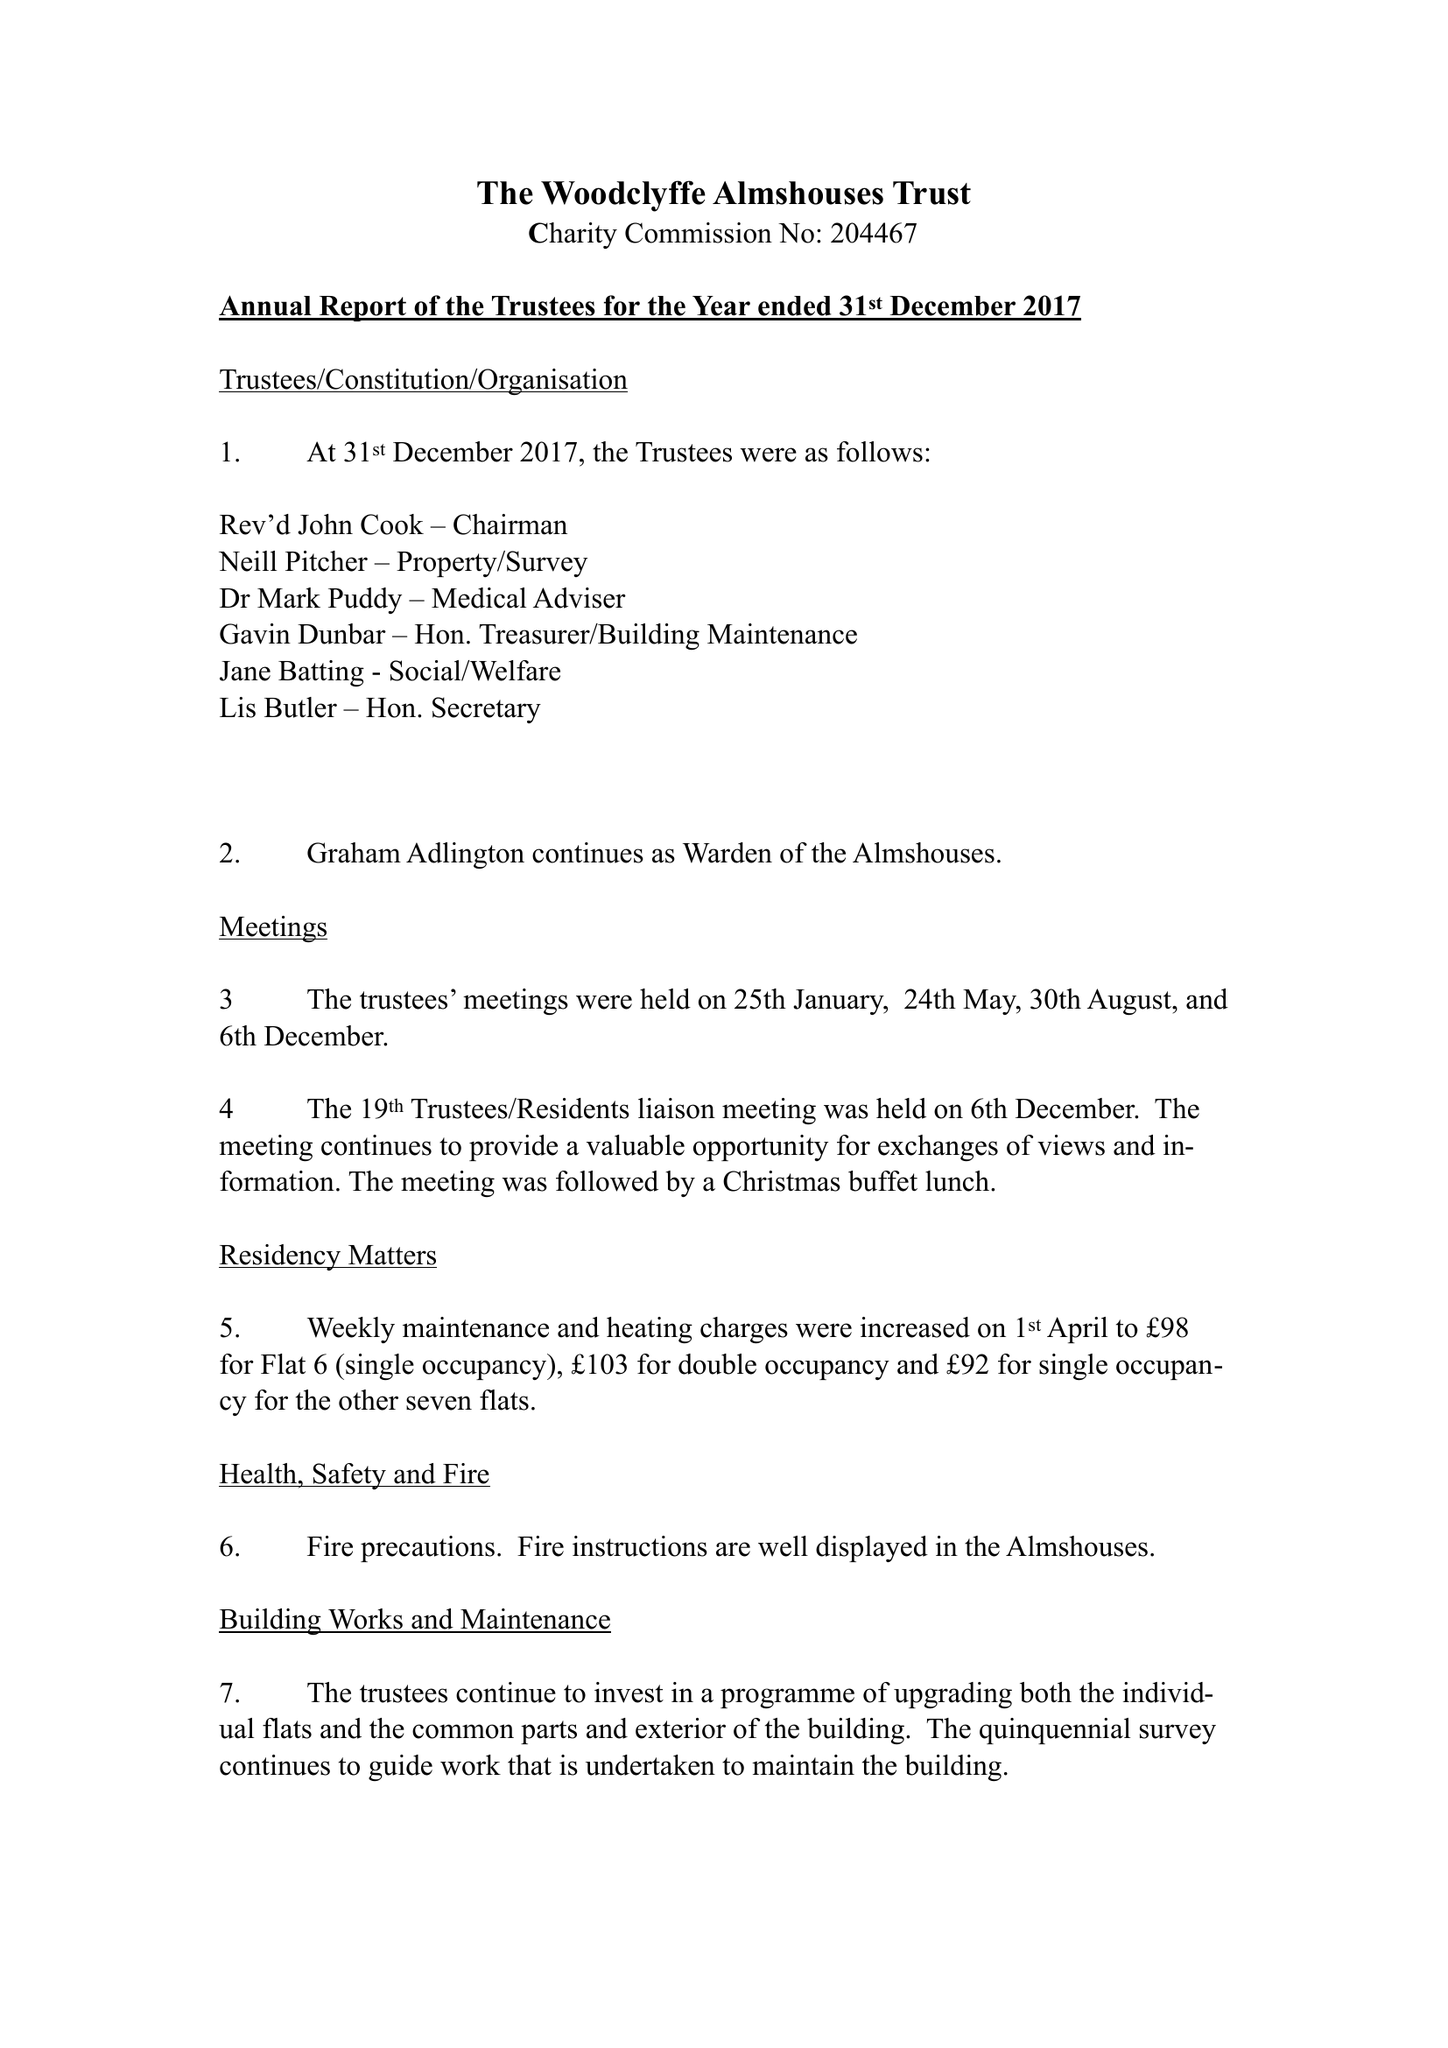What is the value for the address__post_town?
Answer the question using a single word or phrase. READING 